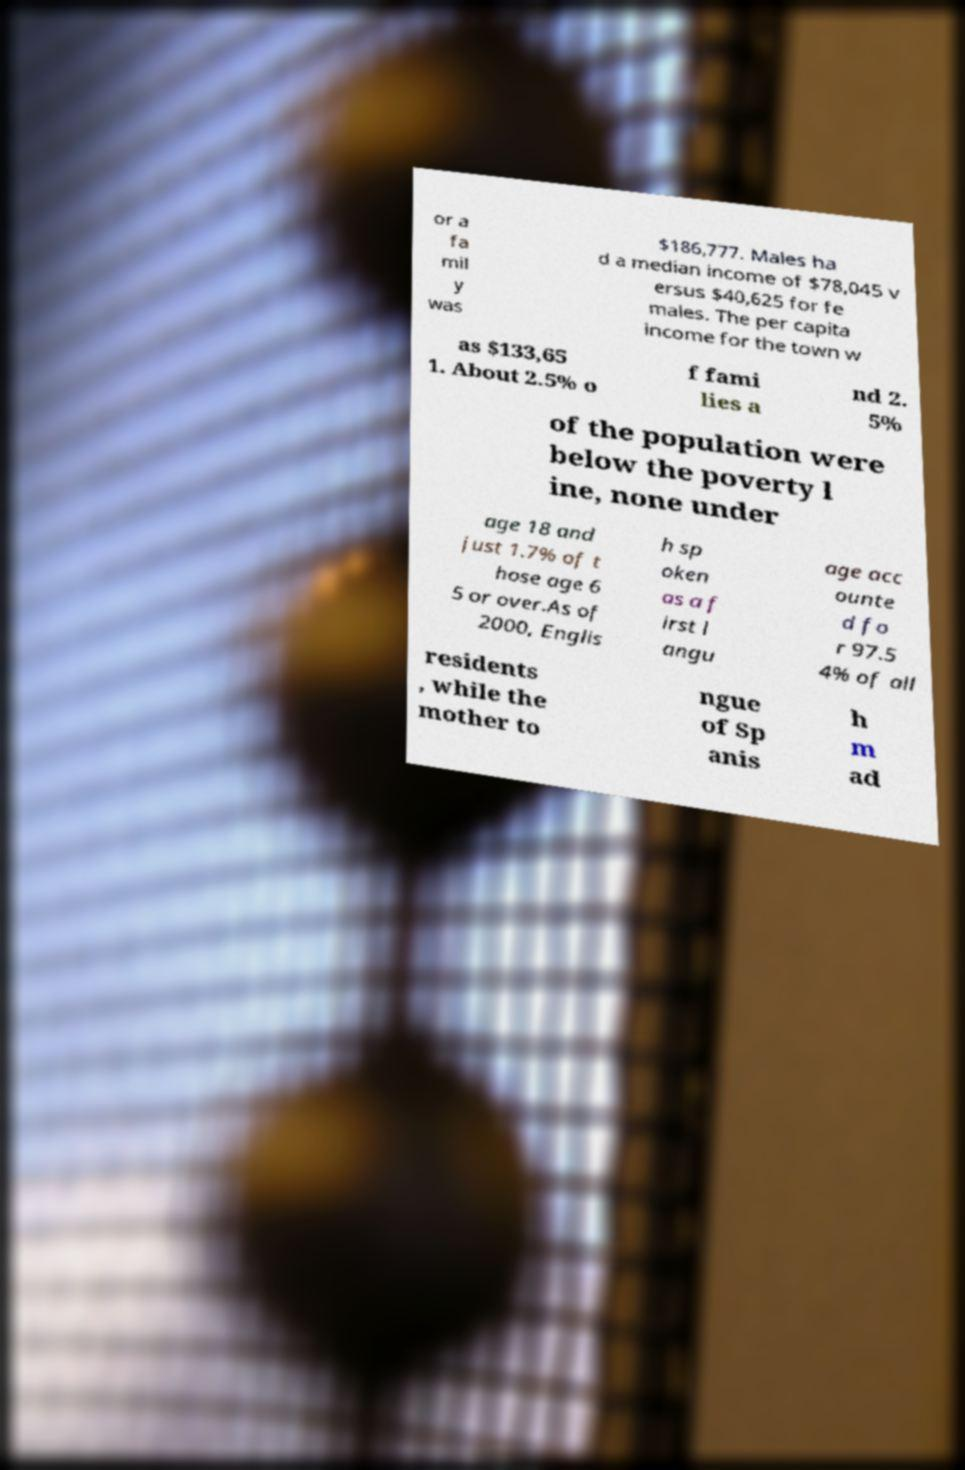There's text embedded in this image that I need extracted. Can you transcribe it verbatim? or a fa mil y was $186,777. Males ha d a median income of $78,045 v ersus $40,625 for fe males. The per capita income for the town w as $133,65 1. About 2.5% o f fami lies a nd 2. 5% of the population were below the poverty l ine, none under age 18 and just 1.7% of t hose age 6 5 or over.As of 2000, Englis h sp oken as a f irst l angu age acc ounte d fo r 97.5 4% of all residents , while the mother to ngue of Sp anis h m ad 